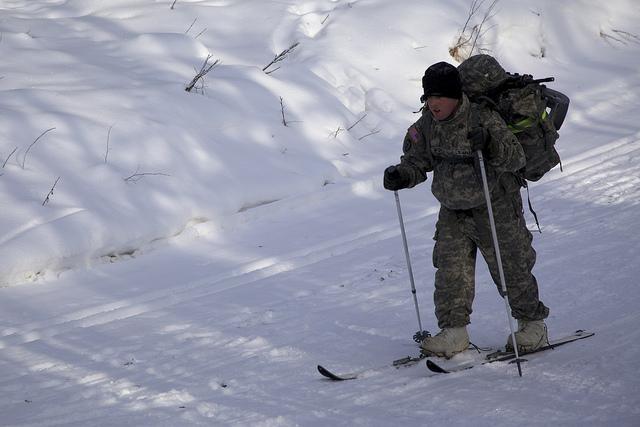Would a person in a swimsuit like this sort of weather pictured here?
Short answer required. No. Is the skier turning or going straight?
Keep it brief. Straight. What pattern is on this person's clothing?
Quick response, please. Camo. Is he wearing a backpack?
Be succinct. Yes. How many skiers are there?
Answer briefly. 1. 